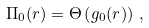Convert formula to latex. <formula><loc_0><loc_0><loc_500><loc_500>\Pi _ { 0 } ( r ) = \Theta \left ( g _ { 0 } ( r ) \right ) \, ,</formula> 